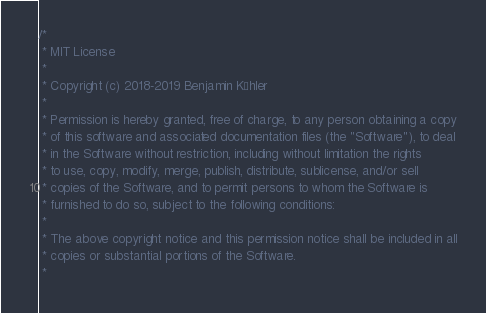Convert code to text. <code><loc_0><loc_0><loc_500><loc_500><_C_>/*
 * MIT License
 *
 * Copyright (c) 2018-2019 Benjamin Köhler
 *
 * Permission is hereby granted, free of charge, to any person obtaining a copy
 * of this software and associated documentation files (the "Software"), to deal
 * in the Software without restriction, including without limitation the rights
 * to use, copy, modify, merge, publish, distribute, sublicense, and/or sell
 * copies of the Software, and to permit persons to whom the Software is
 * furnished to do so, subject to the following conditions:
 *
 * The above copyright notice and this permission notice shall be included in all
 * copies or substantial portions of the Software.
 *</code> 